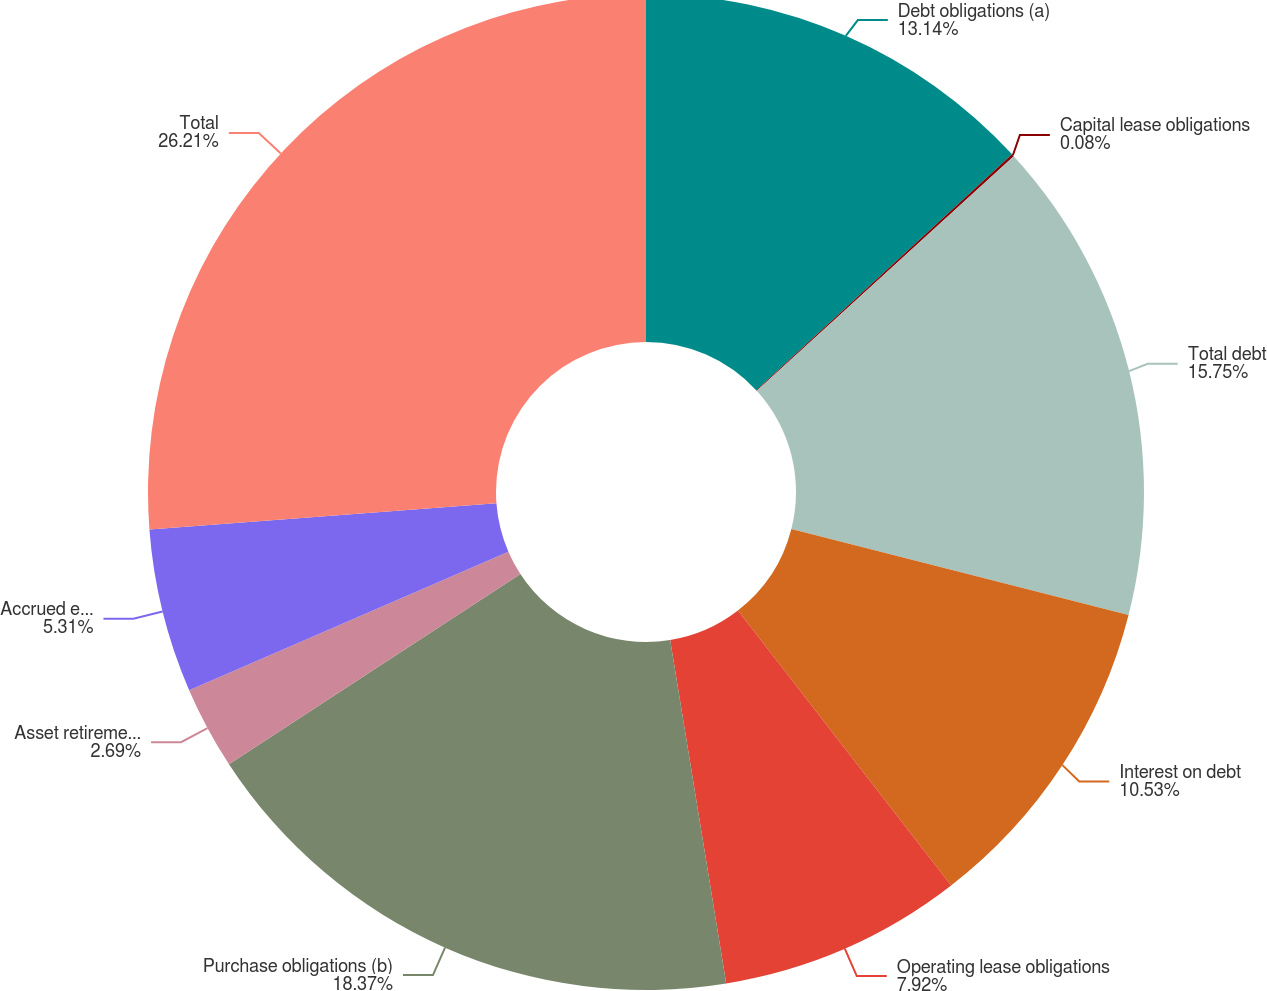Convert chart. <chart><loc_0><loc_0><loc_500><loc_500><pie_chart><fcel>Debt obligations (a)<fcel>Capital lease obligations<fcel>Total debt<fcel>Interest on debt<fcel>Operating lease obligations<fcel>Purchase obligations (b)<fcel>Asset retirement obligations<fcel>Accrued environmental costs<fcel>Total<nl><fcel>13.14%<fcel>0.08%<fcel>15.75%<fcel>10.53%<fcel>7.92%<fcel>18.37%<fcel>2.69%<fcel>5.31%<fcel>26.2%<nl></chart> 